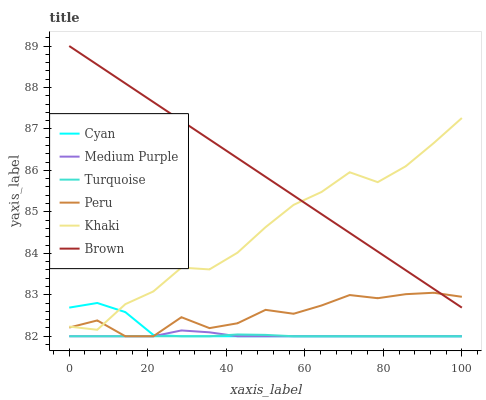Does Turquoise have the minimum area under the curve?
Answer yes or no. Yes. Does Brown have the maximum area under the curve?
Answer yes or no. Yes. Does Khaki have the minimum area under the curve?
Answer yes or no. No. Does Khaki have the maximum area under the curve?
Answer yes or no. No. Is Brown the smoothest?
Answer yes or no. Yes. Is Khaki the roughest?
Answer yes or no. Yes. Is Turquoise the smoothest?
Answer yes or no. No. Is Turquoise the roughest?
Answer yes or no. No. Does Khaki have the lowest value?
Answer yes or no. No. Does Khaki have the highest value?
Answer yes or no. No. Is Medium Purple less than Khaki?
Answer yes or no. Yes. Is Khaki greater than Turquoise?
Answer yes or no. Yes. Does Medium Purple intersect Khaki?
Answer yes or no. No. 